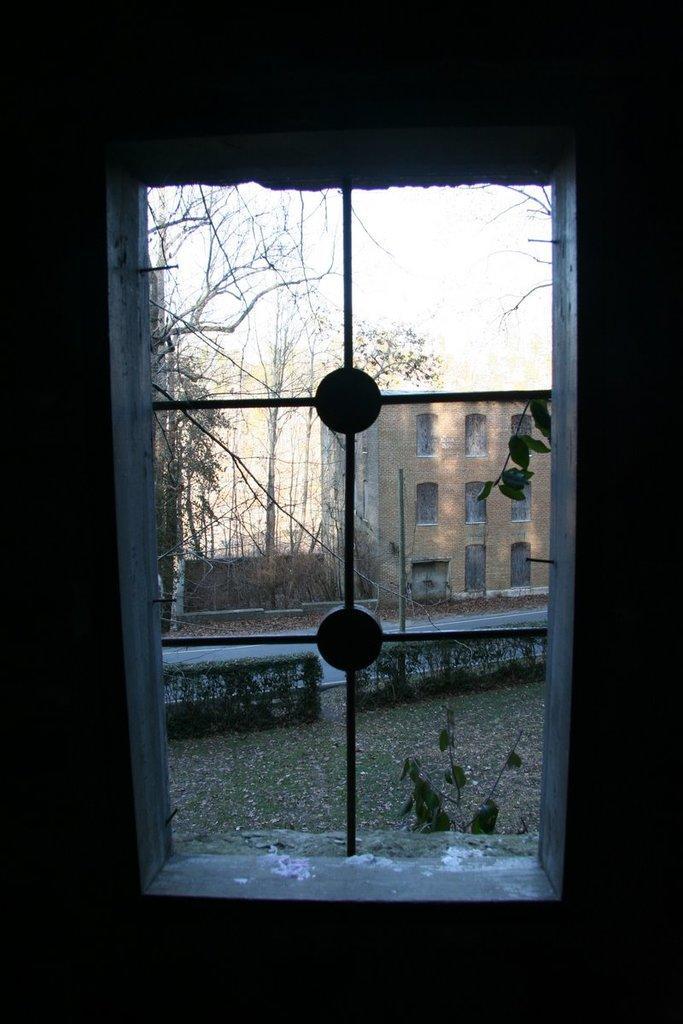Describe this image in one or two sentences. In this image, we can see a window. We can see the ground. We can see some plants, grass. We can see some trees. We can also see a building. We can see the sky. 